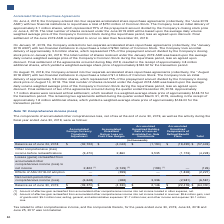According to Lam Research Corporation's financial document, What is the Amount of after-tax gain reclassified from accumulated other comprehensive income into net income located in revenue? According to the financial document, $9.6 million gain. The relevant text states: "hensive income into net income located in revenue: $9.6 million gain; cost of goods sold: $5.0 million loss; selling, general, and administrative expenses: $1.7 million..." Also, What is the Amount of after-tax loss reclassified from accumulated other comprehensive income into net income located in selling, general, and administrative expenses? According to the financial document, $1.7 million loss. The relevant text states: "ss; selling, general, and administrative expenses: $1.7 million loss; and other income and expense: $0.1 million loss...." Also, What is the Amount of after-tax loss reclassified from accumulated other comprehensive income into net income located in cost of goods sold? According to the financial document, $5.0 million loss. The relevant text states: "in revenue: $9.6 million gain; cost of goods sold: $5.0 million loss; selling, general, and administrative expenses: $1.7 million loss; and other income and expense: $0..." Also, can you calculate: What is the percentage change in the total balance from 2018 to 2019? To answer this question, I need to perform calculations using the financial data. The calculation is: (64,030-57,449)/57,449, which equals 11.46 (percentage). This is based on the information: ", 2019 $ (39,370) $ (4,330) $ 2,146 $ (22,476) $ (64,030) 2018 $ (32,722) $ (4,042) $ (1,190) $ (19,495) $ (57,449)..." The key data points involved are: 57,449, 64,030. Also, can you calculate: Under the Accumulated Foreign Currency Translation Adjustment, what is the percentage change in the balance from 2018 to 2019? To answer this question, I need to perform calculations using the financial data. The calculation is: (39,370-32,722)/32,722, which equals 20.32 (percentage). This is based on the information: "Balance as of June 24, 2018 $ (32,722) $ (4,042) $ (1,190) $ (19,495) $ (57,449) Balance as of June 30, 2019 $ (39,370) $ (4,330) $ 2,146 $ (22,476) $ (64,030)..." The key data points involved are: 32,722, 39,370. Also, can you calculate: Under the Accumulated Unrealized Components of Defined Benefit Plans, what is the percentage change in the balance from 2018 to 2019? To answer this question, I need to perform calculations using the financial data. The calculation is: (22,476-19,495)/19,495, which equals 15.29 (percentage). This is based on the information: "f June 24, 2018 $ (32,722) $ (4,042) $ (1,190) $ (19,495) $ (57,449) of June 30, 2019 $ (39,370) $ (4,330) $ 2,146 $ (22,476) $ (64,030)..." The key data points involved are: 19,495, 22,476. 